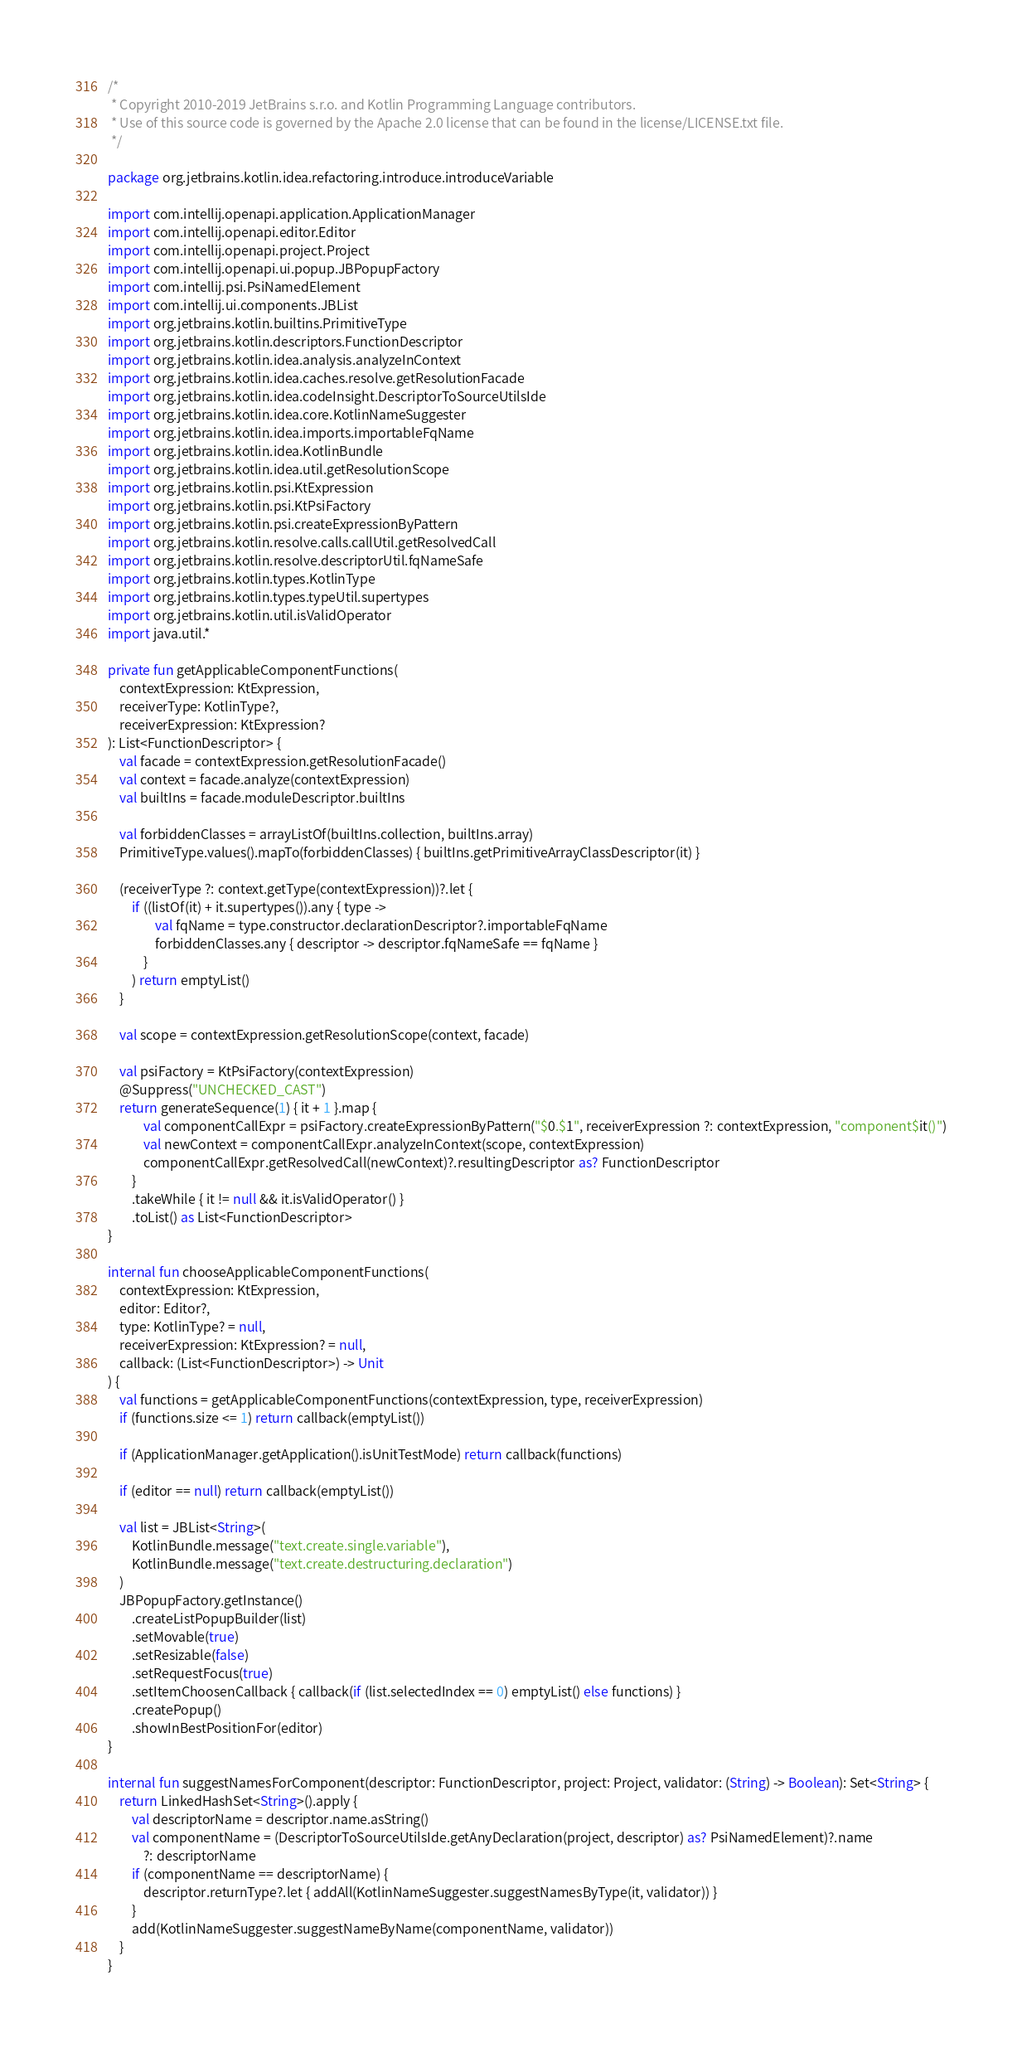<code> <loc_0><loc_0><loc_500><loc_500><_Kotlin_>/*
 * Copyright 2010-2019 JetBrains s.r.o. and Kotlin Programming Language contributors.
 * Use of this source code is governed by the Apache 2.0 license that can be found in the license/LICENSE.txt file.
 */

package org.jetbrains.kotlin.idea.refactoring.introduce.introduceVariable

import com.intellij.openapi.application.ApplicationManager
import com.intellij.openapi.editor.Editor
import com.intellij.openapi.project.Project
import com.intellij.openapi.ui.popup.JBPopupFactory
import com.intellij.psi.PsiNamedElement
import com.intellij.ui.components.JBList
import org.jetbrains.kotlin.builtins.PrimitiveType
import org.jetbrains.kotlin.descriptors.FunctionDescriptor
import org.jetbrains.kotlin.idea.analysis.analyzeInContext
import org.jetbrains.kotlin.idea.caches.resolve.getResolutionFacade
import org.jetbrains.kotlin.idea.codeInsight.DescriptorToSourceUtilsIde
import org.jetbrains.kotlin.idea.core.KotlinNameSuggester
import org.jetbrains.kotlin.idea.imports.importableFqName
import org.jetbrains.kotlin.idea.KotlinBundle
import org.jetbrains.kotlin.idea.util.getResolutionScope
import org.jetbrains.kotlin.psi.KtExpression
import org.jetbrains.kotlin.psi.KtPsiFactory
import org.jetbrains.kotlin.psi.createExpressionByPattern
import org.jetbrains.kotlin.resolve.calls.callUtil.getResolvedCall
import org.jetbrains.kotlin.resolve.descriptorUtil.fqNameSafe
import org.jetbrains.kotlin.types.KotlinType
import org.jetbrains.kotlin.types.typeUtil.supertypes
import org.jetbrains.kotlin.util.isValidOperator
import java.util.*

private fun getApplicableComponentFunctions(
    contextExpression: KtExpression,
    receiverType: KotlinType?,
    receiverExpression: KtExpression?
): List<FunctionDescriptor> {
    val facade = contextExpression.getResolutionFacade()
    val context = facade.analyze(contextExpression)
    val builtIns = facade.moduleDescriptor.builtIns

    val forbiddenClasses = arrayListOf(builtIns.collection, builtIns.array)
    PrimitiveType.values().mapTo(forbiddenClasses) { builtIns.getPrimitiveArrayClassDescriptor(it) }

    (receiverType ?: context.getType(contextExpression))?.let {
        if ((listOf(it) + it.supertypes()).any { type ->
                val fqName = type.constructor.declarationDescriptor?.importableFqName
                forbiddenClasses.any { descriptor -> descriptor.fqNameSafe == fqName }
            }
        ) return emptyList()
    }

    val scope = contextExpression.getResolutionScope(context, facade)

    val psiFactory = KtPsiFactory(contextExpression)
    @Suppress("UNCHECKED_CAST")
    return generateSequence(1) { it + 1 }.map {
            val componentCallExpr = psiFactory.createExpressionByPattern("$0.$1", receiverExpression ?: contextExpression, "component$it()")
            val newContext = componentCallExpr.analyzeInContext(scope, contextExpression)
            componentCallExpr.getResolvedCall(newContext)?.resultingDescriptor as? FunctionDescriptor
        }
        .takeWhile { it != null && it.isValidOperator() }
        .toList() as List<FunctionDescriptor>
}

internal fun chooseApplicableComponentFunctions(
    contextExpression: KtExpression,
    editor: Editor?,
    type: KotlinType? = null,
    receiverExpression: KtExpression? = null,
    callback: (List<FunctionDescriptor>) -> Unit
) {
    val functions = getApplicableComponentFunctions(contextExpression, type, receiverExpression)
    if (functions.size <= 1) return callback(emptyList())

    if (ApplicationManager.getApplication().isUnitTestMode) return callback(functions)

    if (editor == null) return callback(emptyList())

    val list = JBList<String>(
        KotlinBundle.message("text.create.single.variable"),
        KotlinBundle.message("text.create.destructuring.declaration")
    )
    JBPopupFactory.getInstance()
        .createListPopupBuilder(list)
        .setMovable(true)
        .setResizable(false)
        .setRequestFocus(true)
        .setItemChoosenCallback { callback(if (list.selectedIndex == 0) emptyList() else functions) }
        .createPopup()
        .showInBestPositionFor(editor)
}

internal fun suggestNamesForComponent(descriptor: FunctionDescriptor, project: Project, validator: (String) -> Boolean): Set<String> {
    return LinkedHashSet<String>().apply {
        val descriptorName = descriptor.name.asString()
        val componentName = (DescriptorToSourceUtilsIde.getAnyDeclaration(project, descriptor) as? PsiNamedElement)?.name
            ?: descriptorName
        if (componentName == descriptorName) {
            descriptor.returnType?.let { addAll(KotlinNameSuggester.suggestNamesByType(it, validator)) }
        }
        add(KotlinNameSuggester.suggestNameByName(componentName, validator))
    }
}</code> 